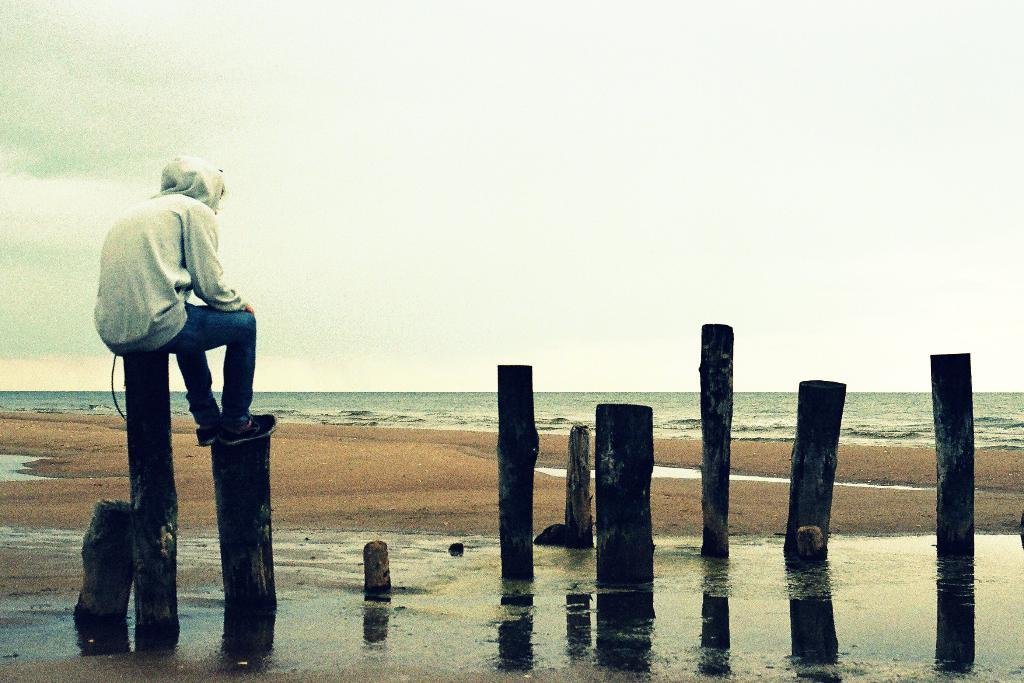What objects are made of wood in the image? There are wooden poles in the image. What is the person in the image doing? A person is sitting on the wooden poles on the left side of the image. What type of surface is in front of the person? There is a sand surface in front of the person. What can be seen in the background of the image? There is a sea visible in the background of the image. What type of ornament is hanging from the wooden poles in the image? There is no ornament hanging from the wooden poles in the image. What type of vegetable is growing on the sand surface in the image? There are no vegetables present in the image; the sand surface is in front of the person sitting on the wooden poles. 